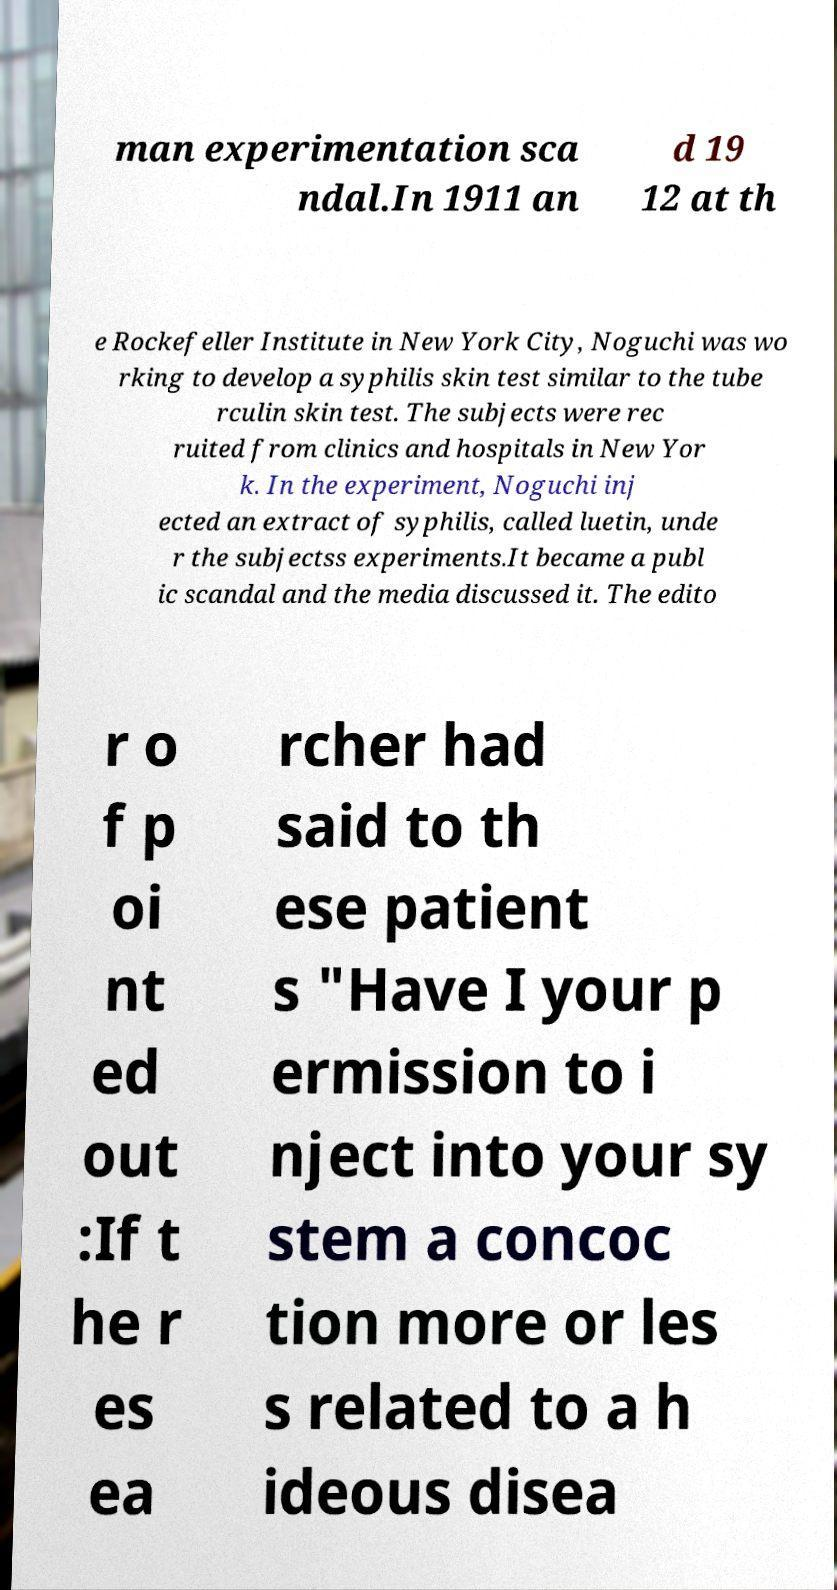Please identify and transcribe the text found in this image. man experimentation sca ndal.In 1911 an d 19 12 at th e Rockefeller Institute in New York City, Noguchi was wo rking to develop a syphilis skin test similar to the tube rculin skin test. The subjects were rec ruited from clinics and hospitals in New Yor k. In the experiment, Noguchi inj ected an extract of syphilis, called luetin, unde r the subjectss experiments.It became a publ ic scandal and the media discussed it. The edito r o f p oi nt ed out :If t he r es ea rcher had said to th ese patient s "Have I your p ermission to i nject into your sy stem a concoc tion more or les s related to a h ideous disea 